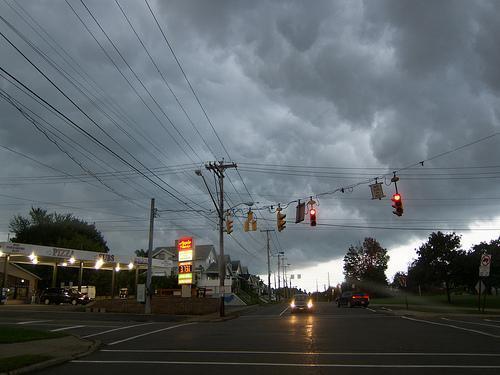How many signs are hanging from the wire?
Give a very brief answer. 2. How many cars are on road?
Give a very brief answer. 2. 